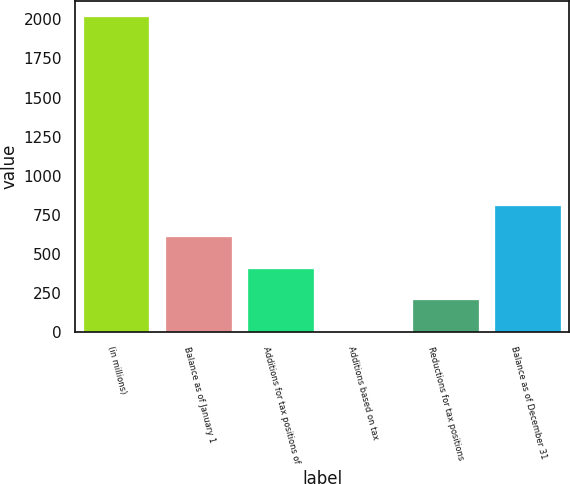Convert chart. <chart><loc_0><loc_0><loc_500><loc_500><bar_chart><fcel>(in millions)<fcel>Balance as of January 1<fcel>Additions for tax positions of<fcel>Additions based on tax<fcel>Reductions for tax positions<fcel>Balance as of December 31<nl><fcel>2017<fcel>605.45<fcel>403.8<fcel>0.5<fcel>202.15<fcel>807.1<nl></chart> 